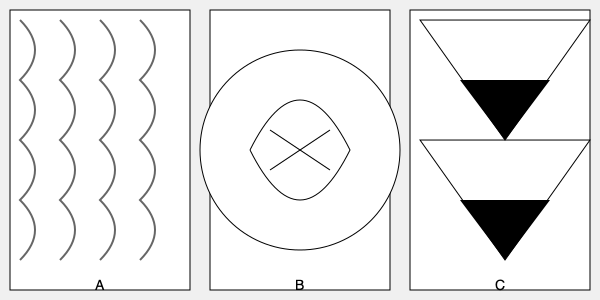Identify the historical fabric patterns shown in the image and match them to their respective eras. Which pattern is associated with the 18th century French decorative style? To answer this question, let's analyze each pattern and its historical context:

1. Pattern A: This shows a repeating, flowing design typical of Damask fabric. Damask originated in the Middle Ages and became popular in Europe during the Renaissance (14th-17th centuries). It's characterized by a single color woven pattern with a contrasting surface appearance.

2. Pattern B: This depicts a scene with figures and landscapes, characteristic of Toile de Jouy. Toile de Jouy (or simply "toile") is a decorative pattern that originated in France in the 18th century. It typically features complex scenes printed on white or off-white cotton, linen, or silk.

3. Pattern C: This shows geometric shapes and bold, symmetrical designs typical of the Art Deco style. Art Deco emerged in the 1920s and 1930s, characterized by its modernity and luxury, often featuring stylized forms and geometric patterns.

Among these patterns, Toile de Jouy (Pattern B) is specifically associated with 18th century French decorative style. It was first produced in Ireland in the mid-18th century and then popularized by the factory of Jouy-en-Josas, near Versailles, France, from 1760 to 1843.
Answer: Pattern B (Toile de Jouy) 